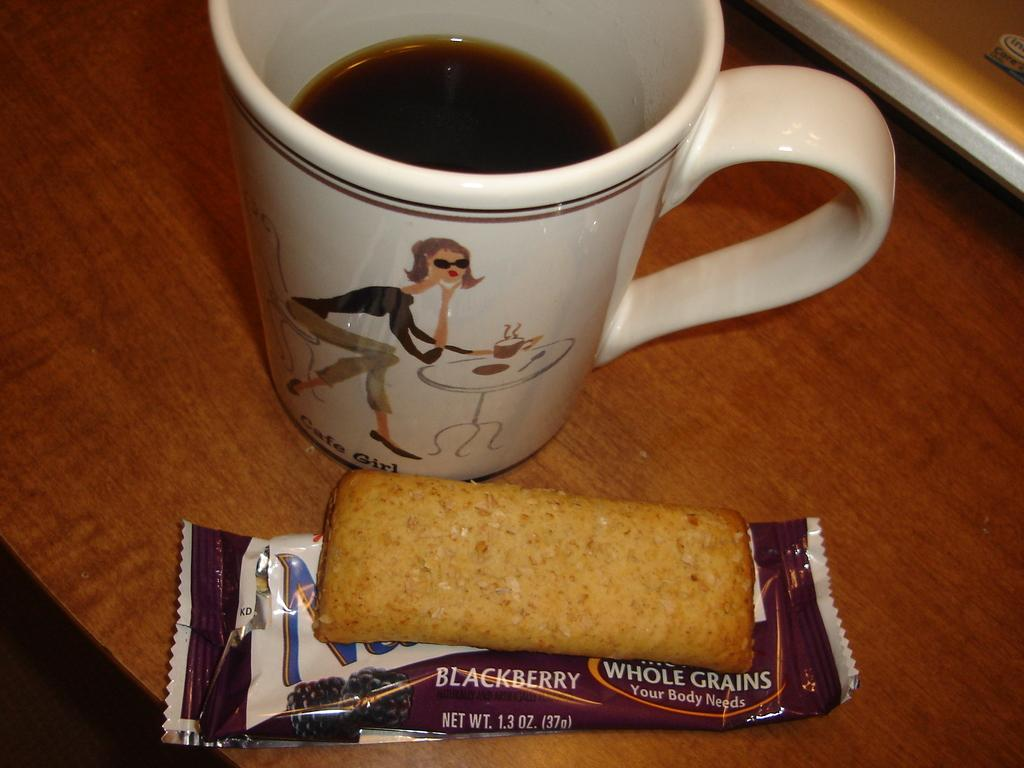What type of food is visible in the image? There is a toast in the image. What type of container is present in the image? There is a white cup in the image. What type of appliance is being used to conduct a science experiment in the image? There is no appliance or science experiment present in the image; it only features a toast and a white cup. How many kittens are visible in the image? There are no kittens present in the image. 